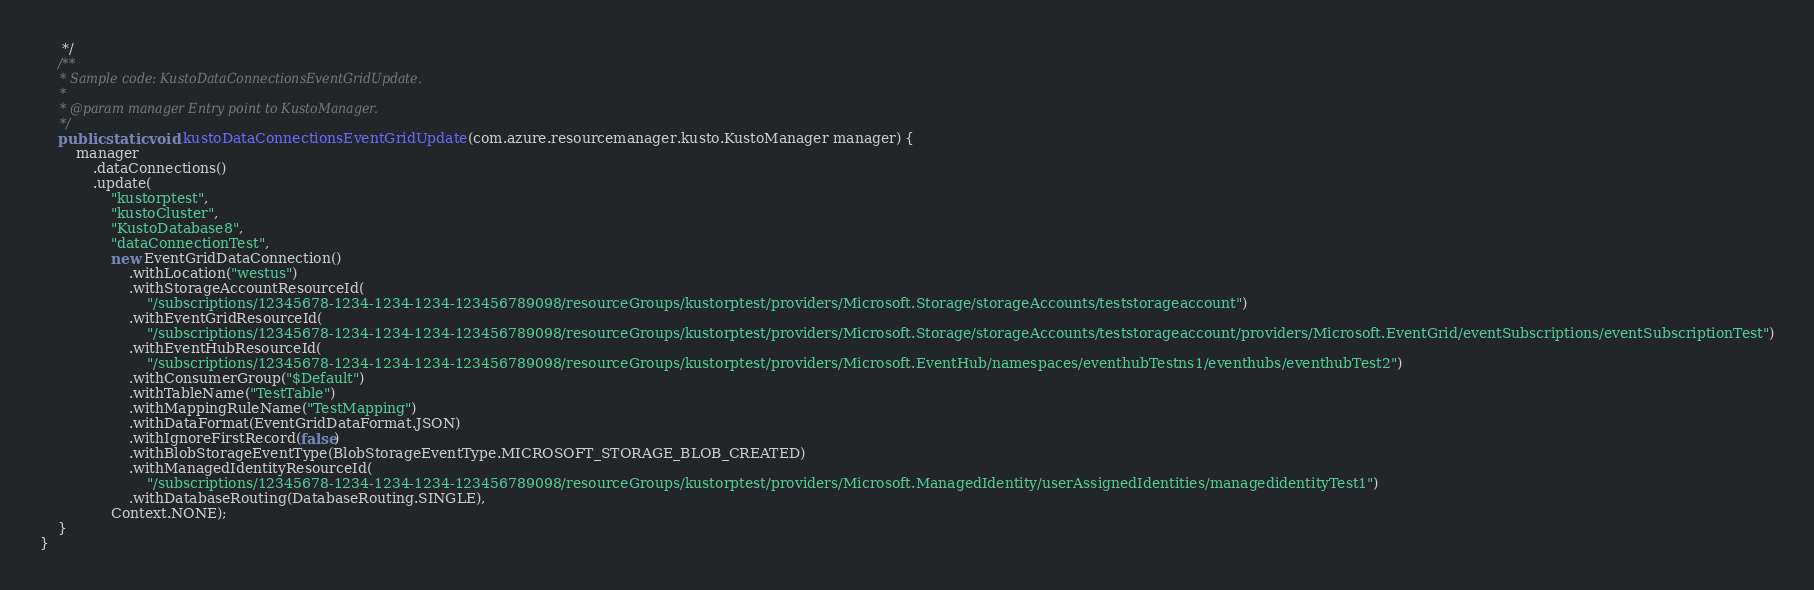<code> <loc_0><loc_0><loc_500><loc_500><_Java_>     */
    /**
     * Sample code: KustoDataConnectionsEventGridUpdate.
     *
     * @param manager Entry point to KustoManager.
     */
    public static void kustoDataConnectionsEventGridUpdate(com.azure.resourcemanager.kusto.KustoManager manager) {
        manager
            .dataConnections()
            .update(
                "kustorptest",
                "kustoCluster",
                "KustoDatabase8",
                "dataConnectionTest",
                new EventGridDataConnection()
                    .withLocation("westus")
                    .withStorageAccountResourceId(
                        "/subscriptions/12345678-1234-1234-1234-123456789098/resourceGroups/kustorptest/providers/Microsoft.Storage/storageAccounts/teststorageaccount")
                    .withEventGridResourceId(
                        "/subscriptions/12345678-1234-1234-1234-123456789098/resourceGroups/kustorptest/providers/Microsoft.Storage/storageAccounts/teststorageaccount/providers/Microsoft.EventGrid/eventSubscriptions/eventSubscriptionTest")
                    .withEventHubResourceId(
                        "/subscriptions/12345678-1234-1234-1234-123456789098/resourceGroups/kustorptest/providers/Microsoft.EventHub/namespaces/eventhubTestns1/eventhubs/eventhubTest2")
                    .withConsumerGroup("$Default")
                    .withTableName("TestTable")
                    .withMappingRuleName("TestMapping")
                    .withDataFormat(EventGridDataFormat.JSON)
                    .withIgnoreFirstRecord(false)
                    .withBlobStorageEventType(BlobStorageEventType.MICROSOFT_STORAGE_BLOB_CREATED)
                    .withManagedIdentityResourceId(
                        "/subscriptions/12345678-1234-1234-1234-123456789098/resourceGroups/kustorptest/providers/Microsoft.ManagedIdentity/userAssignedIdentities/managedidentityTest1")
                    .withDatabaseRouting(DatabaseRouting.SINGLE),
                Context.NONE);
    }
}
</code> 